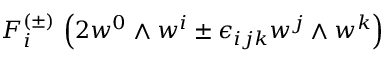Convert formula to latex. <formula><loc_0><loc_0><loc_500><loc_500>F _ { i } ^ { ( \pm ) } \, \left ( 2 w ^ { 0 } \wedge w ^ { i } \pm \epsilon _ { i j k } w ^ { j } \wedge w ^ { k } \right )</formula> 